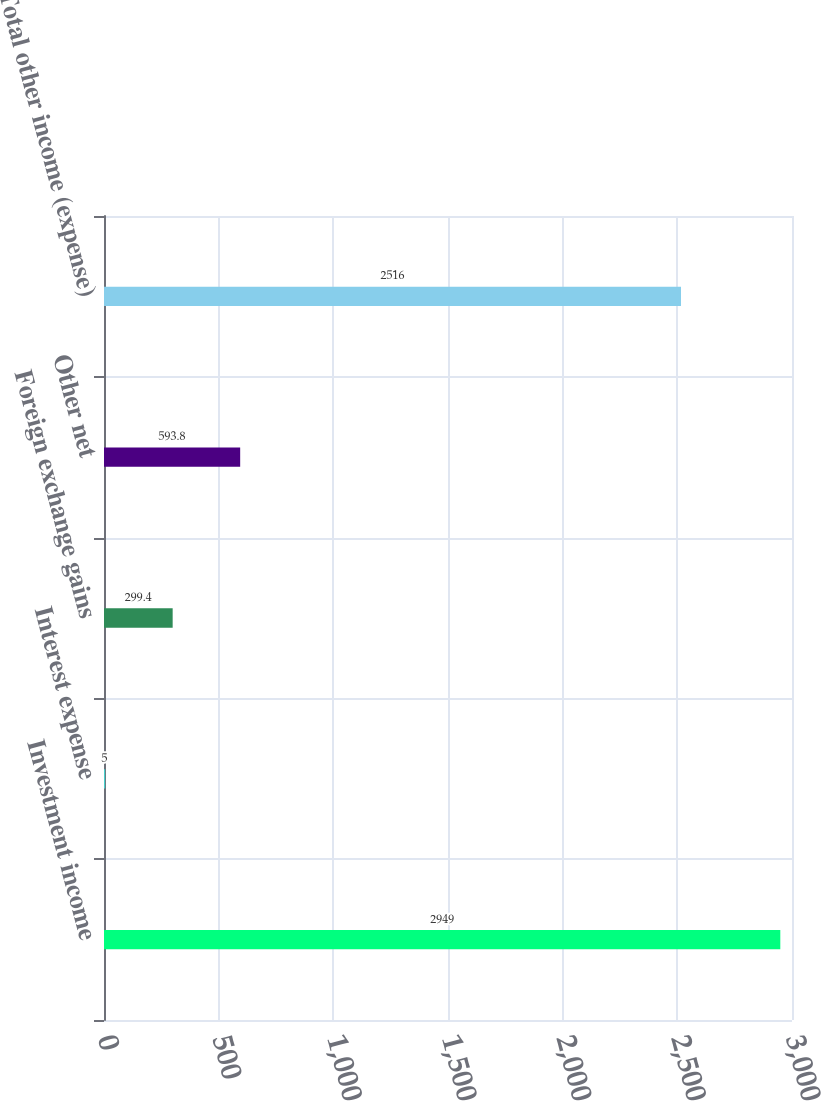Convert chart to OTSL. <chart><loc_0><loc_0><loc_500><loc_500><bar_chart><fcel>Investment income<fcel>Interest expense<fcel>Foreign exchange gains<fcel>Other net<fcel>Total other income (expense)<nl><fcel>2949<fcel>5<fcel>299.4<fcel>593.8<fcel>2516<nl></chart> 